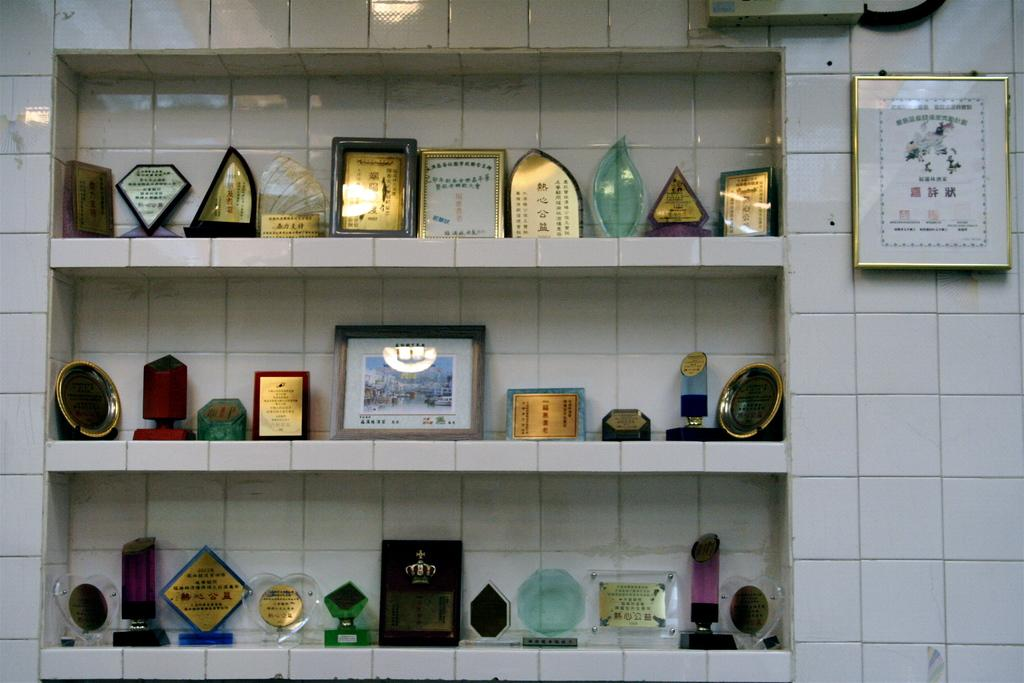What can be seen on the wall in the image? There are frames and shields on the wall in the image. Can you describe the frames on the wall? Unfortunately, the details of the frames cannot be determined from the provided facts. What type of objects are depicted on the shields? The specific designs or images on the shields cannot be determined from the provided facts. How many bananas are hanging from the shields in the image? There are no bananas present in the image; it only features frames and shields on the wall. 